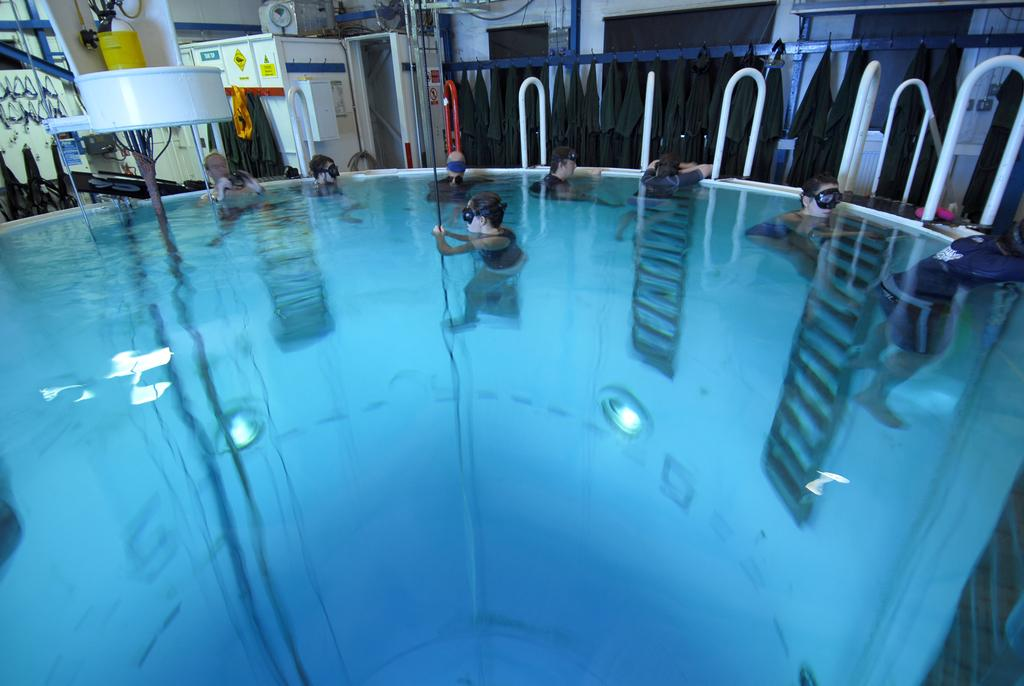What is the main feature in the image? There is a pool in the image. What is happening in the pool? There are people in the pool. What can be seen around the pool? There is equipment and different objects around the pool. Can you see a boy wearing a cap while twisting around in the pool? There is no boy wearing a cap or twisting around in the pool in the image. 